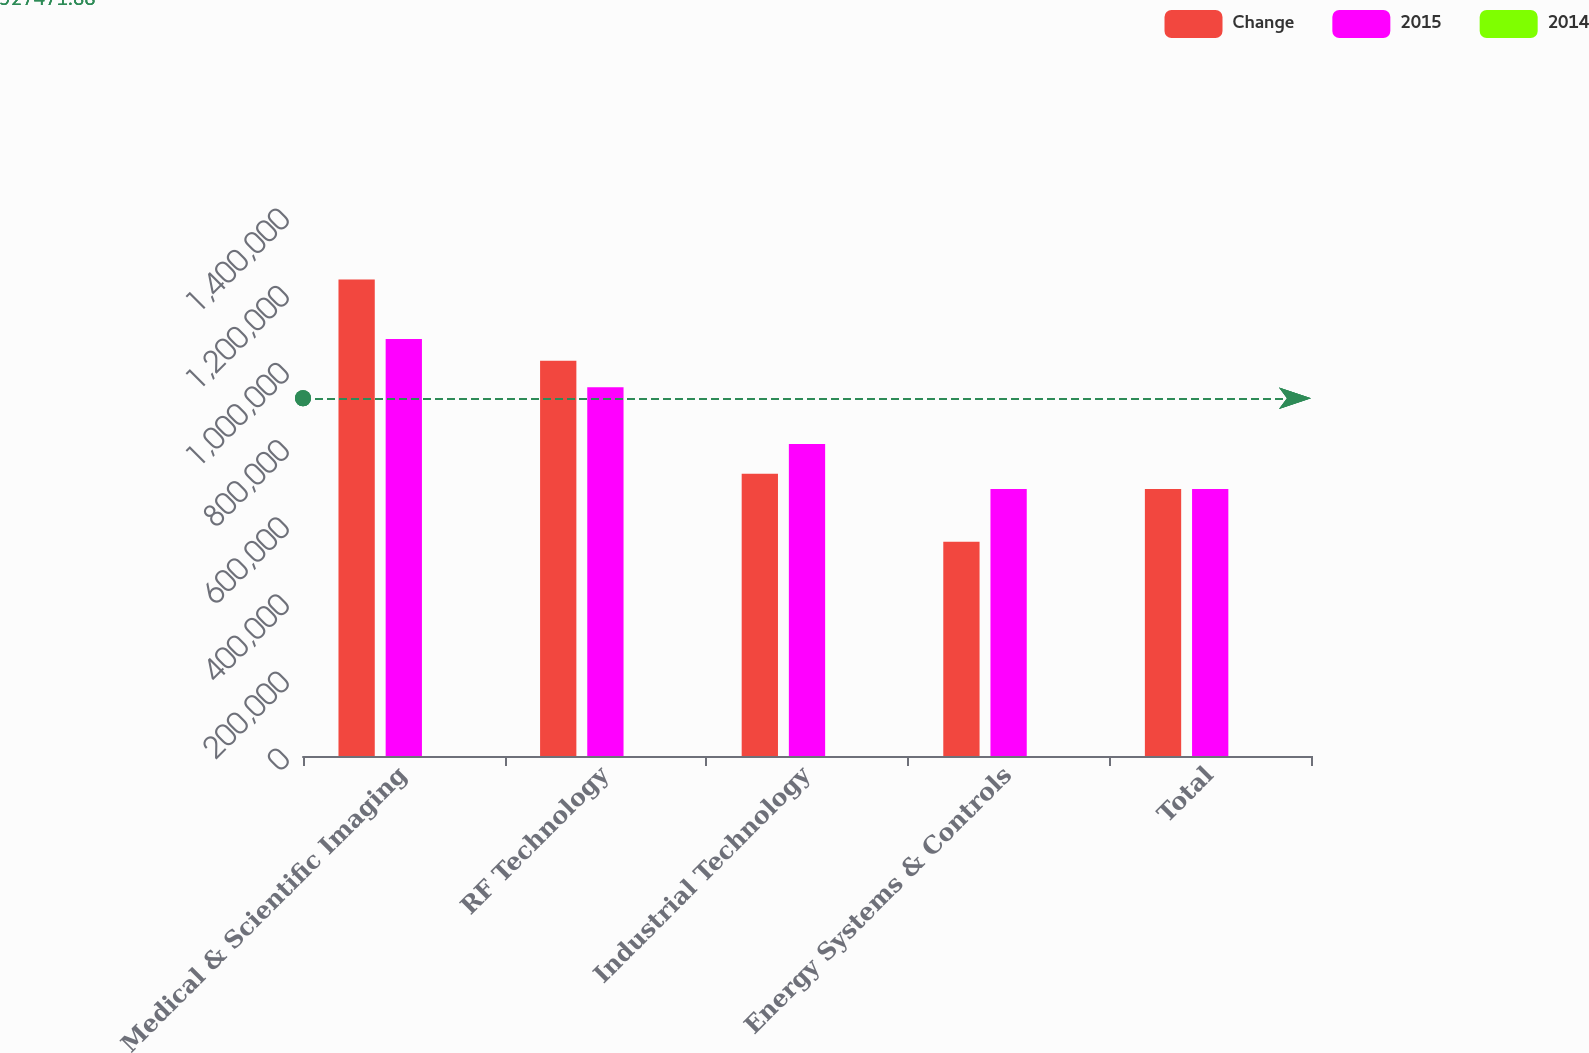Convert chart. <chart><loc_0><loc_0><loc_500><loc_500><stacked_bar_chart><ecel><fcel>Medical & Scientific Imaging<fcel>RF Technology<fcel>Industrial Technology<fcel>Energy Systems & Controls<fcel>Total<nl><fcel>Change<fcel>1.23514e+06<fcel>1.025e+06<fcel>731810<fcel>555672<fcel>692136<nl><fcel>2015<fcel>1.08119e+06<fcel>955831<fcel>808921<fcel>692136<fcel>692136<nl><fcel>2014<fcel>14.2<fcel>7.2<fcel>9.5<fcel>19.7<fcel>0.3<nl></chart> 